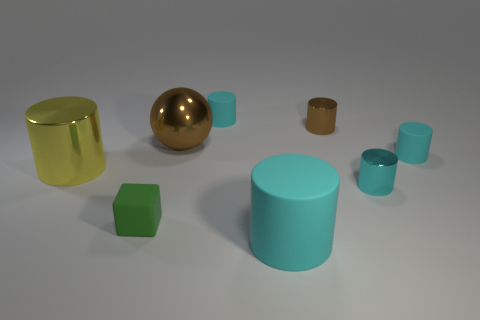Are there any other things that have the same size as the green matte block?
Give a very brief answer. Yes. What shape is the tiny matte thing in front of the matte object right of the big cyan cylinder?
Your answer should be very brief. Cube. Is the material of the brown thing behind the brown sphere the same as the object to the left of the green matte thing?
Make the answer very short. Yes. How many yellow metallic cylinders are behind the small cyan matte cylinder right of the tiny brown shiny cylinder?
Give a very brief answer. 0. There is a large thing in front of the yellow object; does it have the same shape as the matte object left of the large brown thing?
Ensure brevity in your answer.  No. There is a cyan object that is to the left of the small cyan shiny cylinder and behind the small cube; what is its size?
Ensure brevity in your answer.  Small. What is the color of the other big matte object that is the same shape as the big yellow object?
Offer a very short reply. Cyan. What color is the tiny matte cylinder that is in front of the large brown metal ball in front of the brown cylinder?
Ensure brevity in your answer.  Cyan. There is a yellow metal object; what shape is it?
Provide a short and direct response. Cylinder. What is the shape of the cyan object that is in front of the big yellow object and on the right side of the small brown cylinder?
Your response must be concise. Cylinder. 